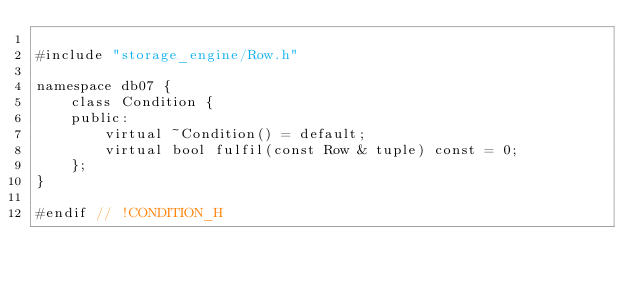<code> <loc_0><loc_0><loc_500><loc_500><_C_>
#include "storage_engine/Row.h"

namespace db07 {
    class Condition {
    public:
	    virtual ~Condition() = default;
	    virtual bool fulfil(const Row & tuple) const = 0;
    };
}

#endif // !CONDITION_H
</code> 